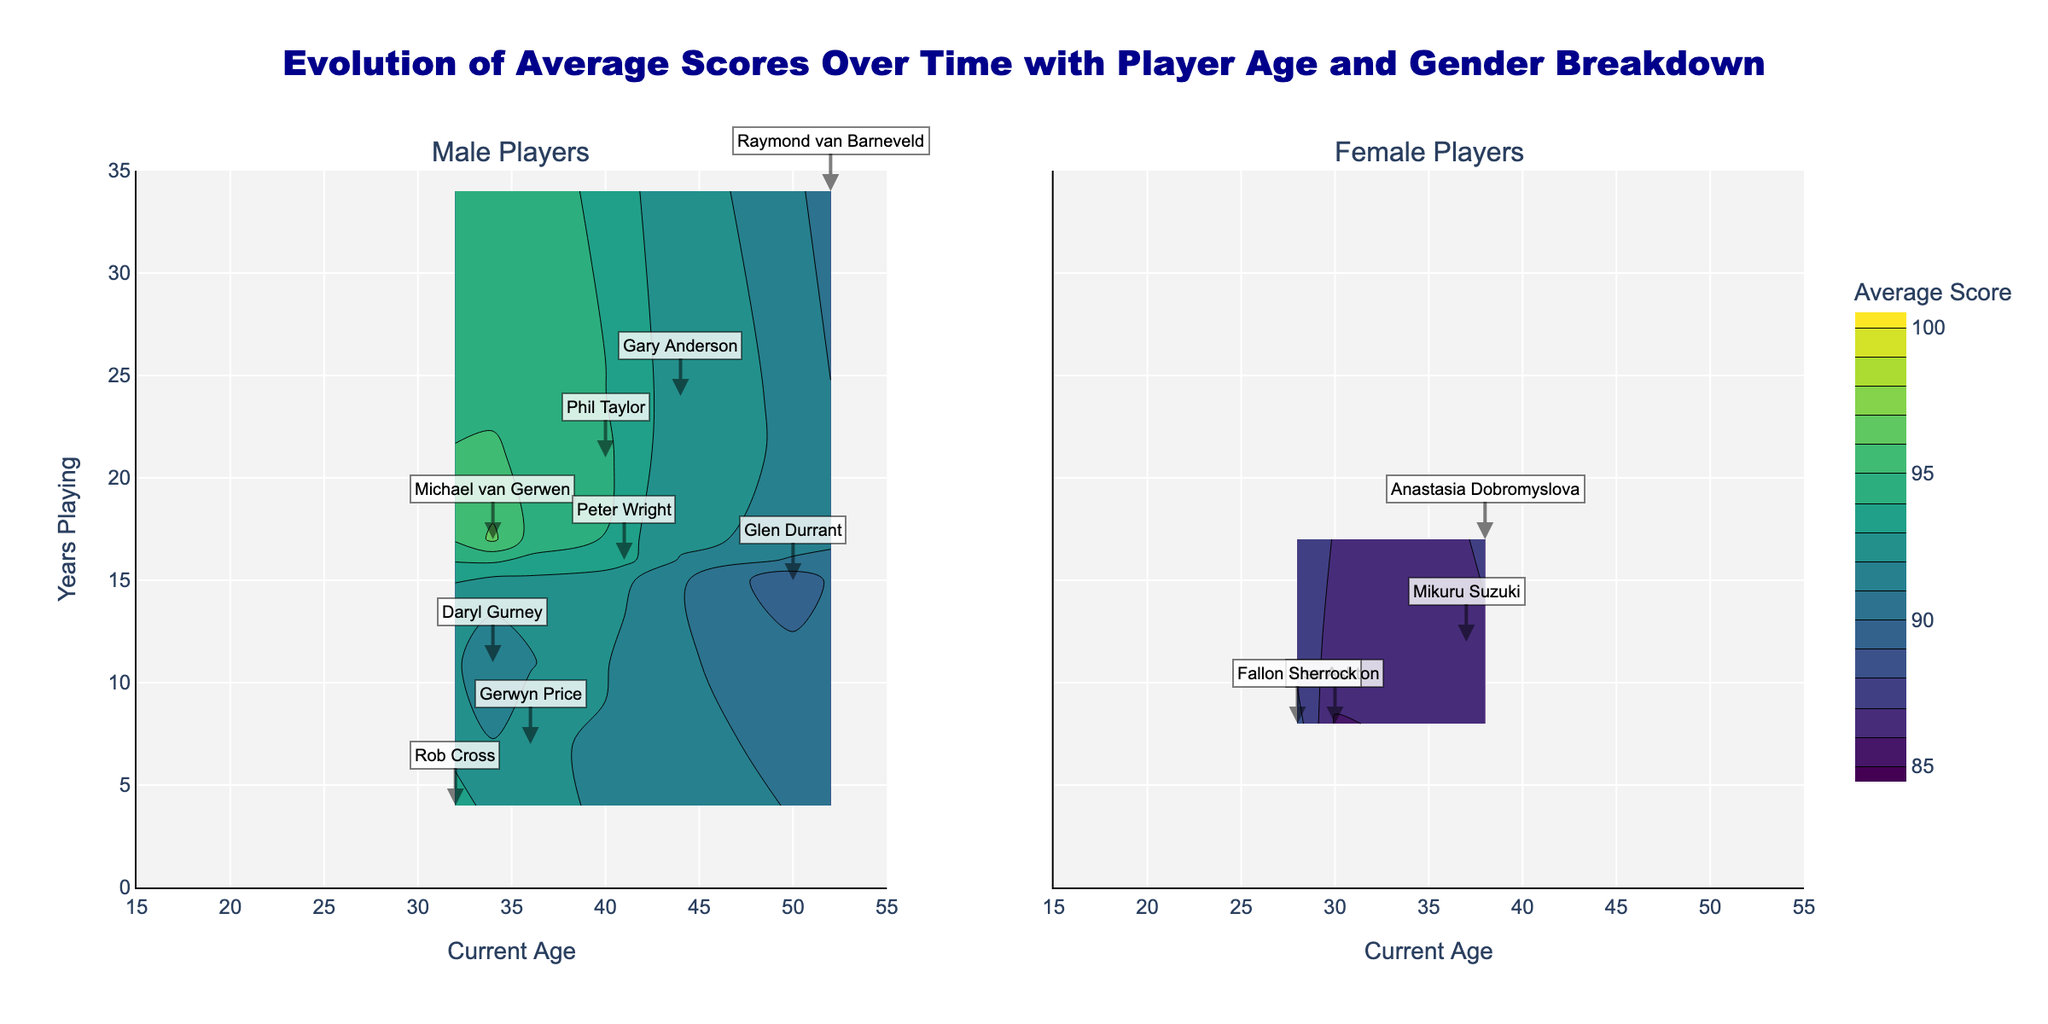What is the title of the figure? The title of the figure is located at the top center and reads 'Evolution of Average Scores Over Time with Player Age and Gender Breakdown'.
Answer: Evolution of Average Scores Over Time with Player Age and Gender Breakdown How many years has the youngest male player been playing? The youngest male player, Rob Cross, is 32 years old. He started playing at 28, so he has been playing for 4 years.
Answer: 4 What is the average score of Lisa Ashton? Lisa Ashton's data point is identified with her name annotation on the right subplot. Her average score is listed next to her name.
Answer: 85.9 Which gender has the wider age range of players? The male players' subplot spans ages from 28 (Rob Cross) to 52 (Raymond van Barneveld), a range of 24 years. The female players' subplot spans ages from 28 (Fallon Sherrock) to 38 (Anastasia Dobromyslova), a range of 10 years.
Answer: Male Among the players shown on the figure, which male player has been playing the longest? From the data annotations, Raymond van Barneveld has been playing for 34 years, which is the longest among the male players.
Answer: Raymond van Barneveld What's the difference in average scores between the highest scoring male and female players? The highest scoring male player, Michael van Gerwen, has an average score of 96.2. The highest scoring female player, Fallon Sherrock, has an average score of 88.4. The difference is 96.2 - 88.4 = 7.8.
Answer: 7.8 Who is the female player with the highest average score and how old is she? From the annotations, Fallon Sherrock has the highest average score among female players at 88.4 and she is 28 years old.
Answer: Fallon Sherrock, 28 Comparing the contours, do male or female players' average scores increase more consistently with years of playing? Examining the contours, male players typically show a more consistent increase in scores with more years of playing, shown by the denser and smoother gradient lines in the male players' subplot.
Answer: Male Who is the oldest player and what is their average score? Raymond van Barneveld is the oldest player at 52 years old, and his average score is 90.1, as indicated by his annotation.
Answer: Raymond van Barneveld, 90.1 Which subplot shows a player who started at the oldest age, and who is this player? Glen Durrant, shown in the male players' subplot, started playing at the oldest age of 35.
Answer: Male, Glen Durrant 